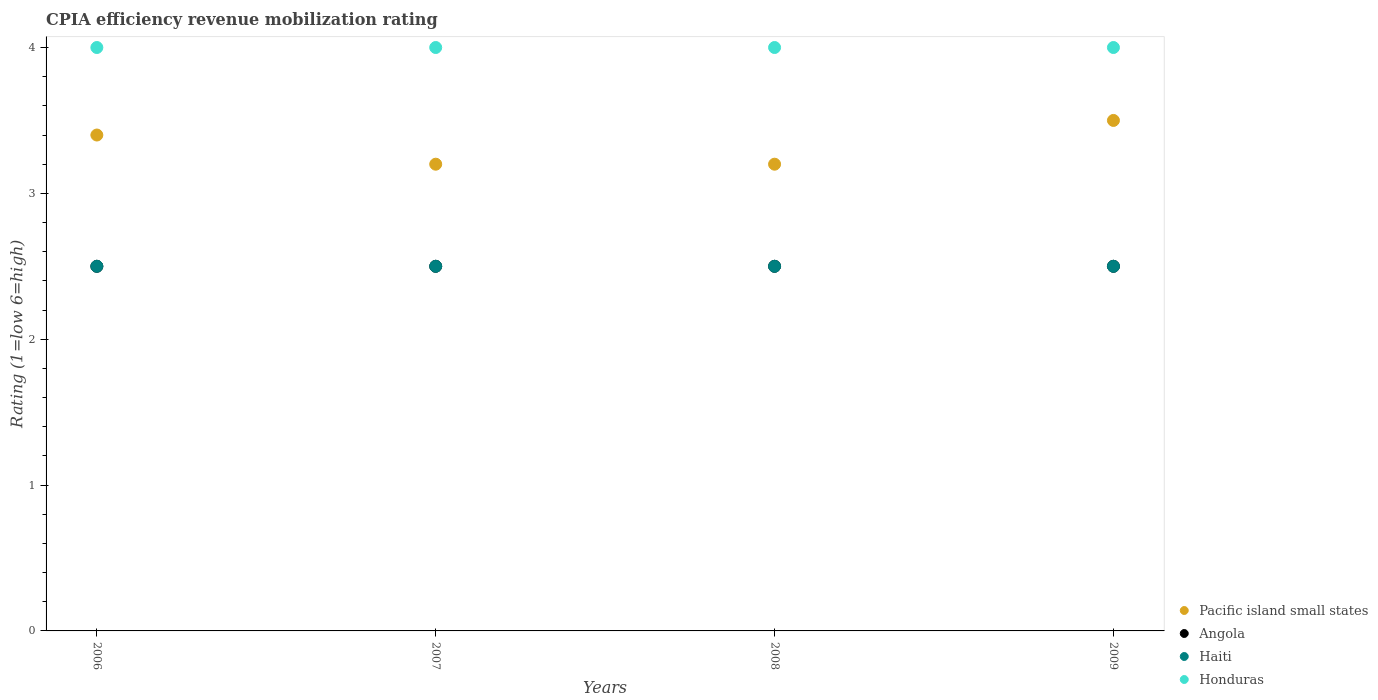How many different coloured dotlines are there?
Your response must be concise. 4. Across all years, what is the maximum CPIA rating in Honduras?
Make the answer very short. 4. In which year was the CPIA rating in Pacific island small states maximum?
Offer a very short reply. 2009. In which year was the CPIA rating in Angola minimum?
Give a very brief answer. 2006. What is the total CPIA rating in Angola in the graph?
Provide a short and direct response. 10. What is the difference between the CPIA rating in Honduras in 2006 and that in 2009?
Your answer should be compact. 0. What is the difference between the CPIA rating in Pacific island small states in 2006 and the CPIA rating in Angola in 2007?
Your answer should be compact. 0.9. What is the average CPIA rating in Pacific island small states per year?
Make the answer very short. 3.33. What is the ratio of the CPIA rating in Pacific island small states in 2008 to that in 2009?
Provide a short and direct response. 0.91. Is the difference between the CPIA rating in Honduras in 2006 and 2009 greater than the difference between the CPIA rating in Haiti in 2006 and 2009?
Offer a very short reply. No. Is it the case that in every year, the sum of the CPIA rating in Haiti and CPIA rating in Honduras  is greater than the sum of CPIA rating in Pacific island small states and CPIA rating in Angola?
Make the answer very short. Yes. Does the CPIA rating in Haiti monotonically increase over the years?
Offer a terse response. No. Is the CPIA rating in Haiti strictly less than the CPIA rating in Pacific island small states over the years?
Keep it short and to the point. Yes. How many dotlines are there?
Offer a very short reply. 4. Are the values on the major ticks of Y-axis written in scientific E-notation?
Offer a very short reply. No. Does the graph contain any zero values?
Your response must be concise. No. How many legend labels are there?
Make the answer very short. 4. How are the legend labels stacked?
Provide a succinct answer. Vertical. What is the title of the graph?
Your answer should be compact. CPIA efficiency revenue mobilization rating. Does "Low income" appear as one of the legend labels in the graph?
Your answer should be compact. No. What is the label or title of the X-axis?
Give a very brief answer. Years. What is the label or title of the Y-axis?
Provide a short and direct response. Rating (1=low 6=high). What is the Rating (1=low 6=high) in Pacific island small states in 2006?
Your answer should be compact. 3.4. What is the Rating (1=low 6=high) of Angola in 2006?
Ensure brevity in your answer.  2.5. What is the Rating (1=low 6=high) of Pacific island small states in 2007?
Provide a short and direct response. 3.2. What is the Rating (1=low 6=high) of Haiti in 2007?
Give a very brief answer. 2.5. What is the Rating (1=low 6=high) in Honduras in 2007?
Provide a succinct answer. 4. What is the Rating (1=low 6=high) of Angola in 2009?
Give a very brief answer. 2.5. What is the Rating (1=low 6=high) of Honduras in 2009?
Provide a short and direct response. 4. Across all years, what is the maximum Rating (1=low 6=high) in Pacific island small states?
Keep it short and to the point. 3.5. Across all years, what is the maximum Rating (1=low 6=high) of Haiti?
Offer a terse response. 2.5. Across all years, what is the minimum Rating (1=low 6=high) of Honduras?
Your answer should be very brief. 4. What is the total Rating (1=low 6=high) in Haiti in the graph?
Keep it short and to the point. 10. What is the total Rating (1=low 6=high) of Honduras in the graph?
Make the answer very short. 16. What is the difference between the Rating (1=low 6=high) in Angola in 2006 and that in 2007?
Offer a terse response. 0. What is the difference between the Rating (1=low 6=high) of Honduras in 2006 and that in 2007?
Keep it short and to the point. 0. What is the difference between the Rating (1=low 6=high) in Angola in 2006 and that in 2008?
Keep it short and to the point. 0. What is the difference between the Rating (1=low 6=high) of Haiti in 2006 and that in 2008?
Your response must be concise. 0. What is the difference between the Rating (1=low 6=high) of Pacific island small states in 2006 and that in 2009?
Your response must be concise. -0.1. What is the difference between the Rating (1=low 6=high) of Angola in 2006 and that in 2009?
Your answer should be very brief. 0. What is the difference between the Rating (1=low 6=high) in Haiti in 2006 and that in 2009?
Provide a short and direct response. 0. What is the difference between the Rating (1=low 6=high) of Honduras in 2006 and that in 2009?
Make the answer very short. 0. What is the difference between the Rating (1=low 6=high) of Pacific island small states in 2007 and that in 2008?
Offer a terse response. 0. What is the difference between the Rating (1=low 6=high) in Angola in 2007 and that in 2008?
Keep it short and to the point. 0. What is the difference between the Rating (1=low 6=high) of Pacific island small states in 2007 and that in 2009?
Provide a short and direct response. -0.3. What is the difference between the Rating (1=low 6=high) in Haiti in 2008 and that in 2009?
Offer a terse response. 0. What is the difference between the Rating (1=low 6=high) of Honduras in 2008 and that in 2009?
Keep it short and to the point. 0. What is the difference between the Rating (1=low 6=high) of Angola in 2006 and the Rating (1=low 6=high) of Haiti in 2007?
Offer a terse response. 0. What is the difference between the Rating (1=low 6=high) in Angola in 2006 and the Rating (1=low 6=high) in Honduras in 2007?
Give a very brief answer. -1.5. What is the difference between the Rating (1=low 6=high) of Angola in 2006 and the Rating (1=low 6=high) of Honduras in 2008?
Give a very brief answer. -1.5. What is the difference between the Rating (1=low 6=high) of Haiti in 2006 and the Rating (1=low 6=high) of Honduras in 2008?
Your response must be concise. -1.5. What is the difference between the Rating (1=low 6=high) of Pacific island small states in 2006 and the Rating (1=low 6=high) of Angola in 2009?
Your answer should be compact. 0.9. What is the difference between the Rating (1=low 6=high) in Angola in 2006 and the Rating (1=low 6=high) in Haiti in 2009?
Your answer should be very brief. 0. What is the difference between the Rating (1=low 6=high) of Pacific island small states in 2007 and the Rating (1=low 6=high) of Angola in 2008?
Provide a succinct answer. 0.7. What is the difference between the Rating (1=low 6=high) in Pacific island small states in 2007 and the Rating (1=low 6=high) in Honduras in 2008?
Make the answer very short. -0.8. What is the difference between the Rating (1=low 6=high) in Angola in 2007 and the Rating (1=low 6=high) in Haiti in 2008?
Your answer should be very brief. 0. What is the difference between the Rating (1=low 6=high) of Haiti in 2007 and the Rating (1=low 6=high) of Honduras in 2008?
Keep it short and to the point. -1.5. What is the difference between the Rating (1=low 6=high) of Pacific island small states in 2007 and the Rating (1=low 6=high) of Angola in 2009?
Provide a succinct answer. 0.7. What is the difference between the Rating (1=low 6=high) in Haiti in 2007 and the Rating (1=low 6=high) in Honduras in 2009?
Offer a very short reply. -1.5. What is the difference between the Rating (1=low 6=high) in Pacific island small states in 2008 and the Rating (1=low 6=high) in Angola in 2009?
Offer a terse response. 0.7. What is the difference between the Rating (1=low 6=high) of Pacific island small states in 2008 and the Rating (1=low 6=high) of Haiti in 2009?
Provide a succinct answer. 0.7. What is the difference between the Rating (1=low 6=high) of Pacific island small states in 2008 and the Rating (1=low 6=high) of Honduras in 2009?
Your answer should be compact. -0.8. What is the difference between the Rating (1=low 6=high) of Haiti in 2008 and the Rating (1=low 6=high) of Honduras in 2009?
Ensure brevity in your answer.  -1.5. What is the average Rating (1=low 6=high) in Pacific island small states per year?
Offer a very short reply. 3.33. What is the average Rating (1=low 6=high) in Angola per year?
Provide a succinct answer. 2.5. In the year 2006, what is the difference between the Rating (1=low 6=high) in Pacific island small states and Rating (1=low 6=high) in Honduras?
Give a very brief answer. -0.6. In the year 2006, what is the difference between the Rating (1=low 6=high) in Angola and Rating (1=low 6=high) in Haiti?
Provide a succinct answer. 0. In the year 2006, what is the difference between the Rating (1=low 6=high) of Angola and Rating (1=low 6=high) of Honduras?
Your response must be concise. -1.5. In the year 2006, what is the difference between the Rating (1=low 6=high) in Haiti and Rating (1=low 6=high) in Honduras?
Offer a terse response. -1.5. In the year 2007, what is the difference between the Rating (1=low 6=high) in Pacific island small states and Rating (1=low 6=high) in Angola?
Offer a terse response. 0.7. In the year 2007, what is the difference between the Rating (1=low 6=high) of Pacific island small states and Rating (1=low 6=high) of Haiti?
Keep it short and to the point. 0.7. In the year 2007, what is the difference between the Rating (1=low 6=high) in Angola and Rating (1=low 6=high) in Haiti?
Provide a succinct answer. 0. In the year 2008, what is the difference between the Rating (1=low 6=high) in Pacific island small states and Rating (1=low 6=high) in Haiti?
Provide a succinct answer. 0.7. In the year 2008, what is the difference between the Rating (1=low 6=high) in Haiti and Rating (1=low 6=high) in Honduras?
Provide a short and direct response. -1.5. In the year 2009, what is the difference between the Rating (1=low 6=high) in Pacific island small states and Rating (1=low 6=high) in Haiti?
Give a very brief answer. 1. In the year 2009, what is the difference between the Rating (1=low 6=high) in Angola and Rating (1=low 6=high) in Honduras?
Give a very brief answer. -1.5. What is the ratio of the Rating (1=low 6=high) of Pacific island small states in 2006 to that in 2007?
Keep it short and to the point. 1.06. What is the ratio of the Rating (1=low 6=high) of Haiti in 2006 to that in 2007?
Offer a terse response. 1. What is the ratio of the Rating (1=low 6=high) in Angola in 2006 to that in 2008?
Give a very brief answer. 1. What is the ratio of the Rating (1=low 6=high) in Pacific island small states in 2006 to that in 2009?
Keep it short and to the point. 0.97. What is the ratio of the Rating (1=low 6=high) in Angola in 2006 to that in 2009?
Provide a succinct answer. 1. What is the ratio of the Rating (1=low 6=high) in Honduras in 2006 to that in 2009?
Provide a short and direct response. 1. What is the ratio of the Rating (1=low 6=high) of Pacific island small states in 2007 to that in 2008?
Ensure brevity in your answer.  1. What is the ratio of the Rating (1=low 6=high) in Angola in 2007 to that in 2008?
Provide a short and direct response. 1. What is the ratio of the Rating (1=low 6=high) of Haiti in 2007 to that in 2008?
Offer a terse response. 1. What is the ratio of the Rating (1=low 6=high) of Honduras in 2007 to that in 2008?
Ensure brevity in your answer.  1. What is the ratio of the Rating (1=low 6=high) of Pacific island small states in 2007 to that in 2009?
Offer a very short reply. 0.91. What is the ratio of the Rating (1=low 6=high) of Angola in 2007 to that in 2009?
Offer a very short reply. 1. What is the ratio of the Rating (1=low 6=high) in Honduras in 2007 to that in 2009?
Keep it short and to the point. 1. What is the ratio of the Rating (1=low 6=high) of Pacific island small states in 2008 to that in 2009?
Your answer should be very brief. 0.91. What is the ratio of the Rating (1=low 6=high) of Angola in 2008 to that in 2009?
Your answer should be very brief. 1. What is the ratio of the Rating (1=low 6=high) in Haiti in 2008 to that in 2009?
Offer a very short reply. 1. What is the difference between the highest and the lowest Rating (1=low 6=high) in Pacific island small states?
Make the answer very short. 0.3. 